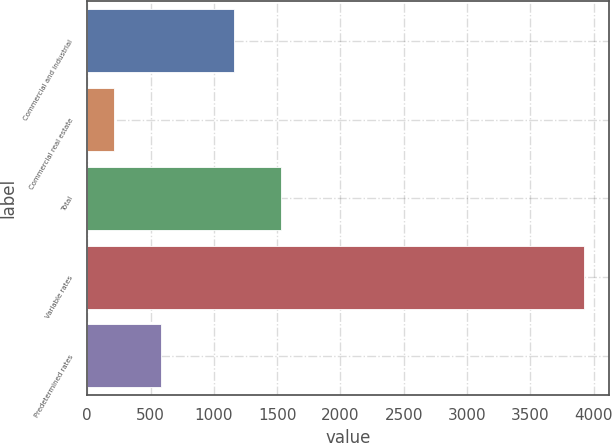Convert chart to OTSL. <chart><loc_0><loc_0><loc_500><loc_500><bar_chart><fcel>Commercial and industrial<fcel>Commercial real estate<fcel>Total<fcel>Variable rates<fcel>Predetermined rates<nl><fcel>1159.6<fcel>210.6<fcel>1531.22<fcel>3926.8<fcel>582.22<nl></chart> 